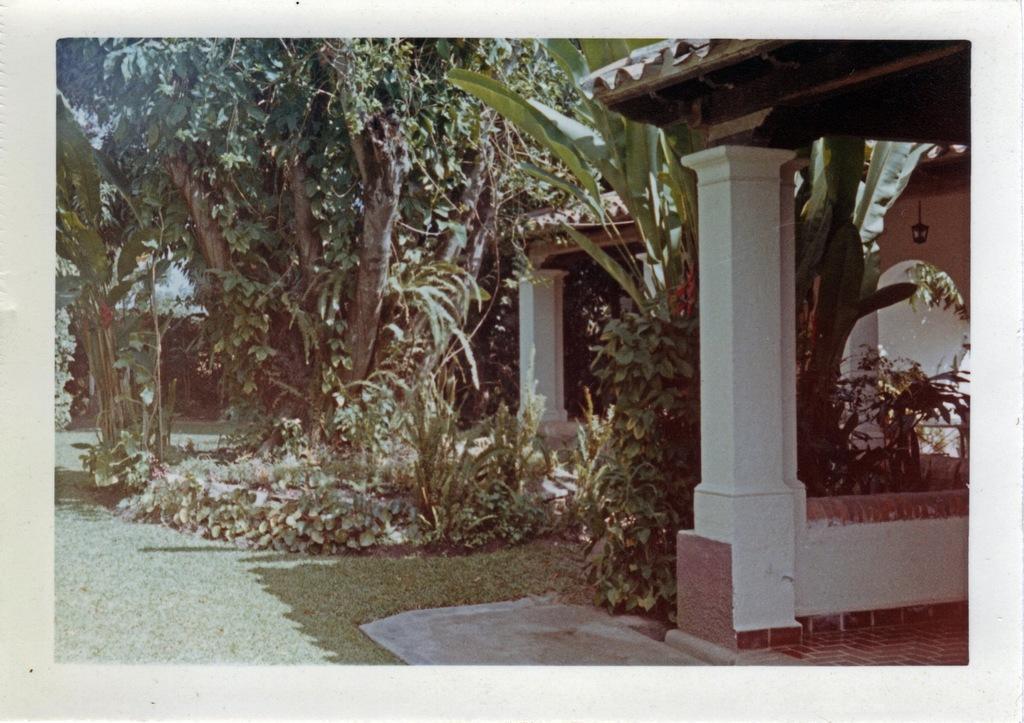Describe this image in one or two sentences. In this image we can see a picture of a house with roof and pillars. We can also see some plants, grass and the trees. 